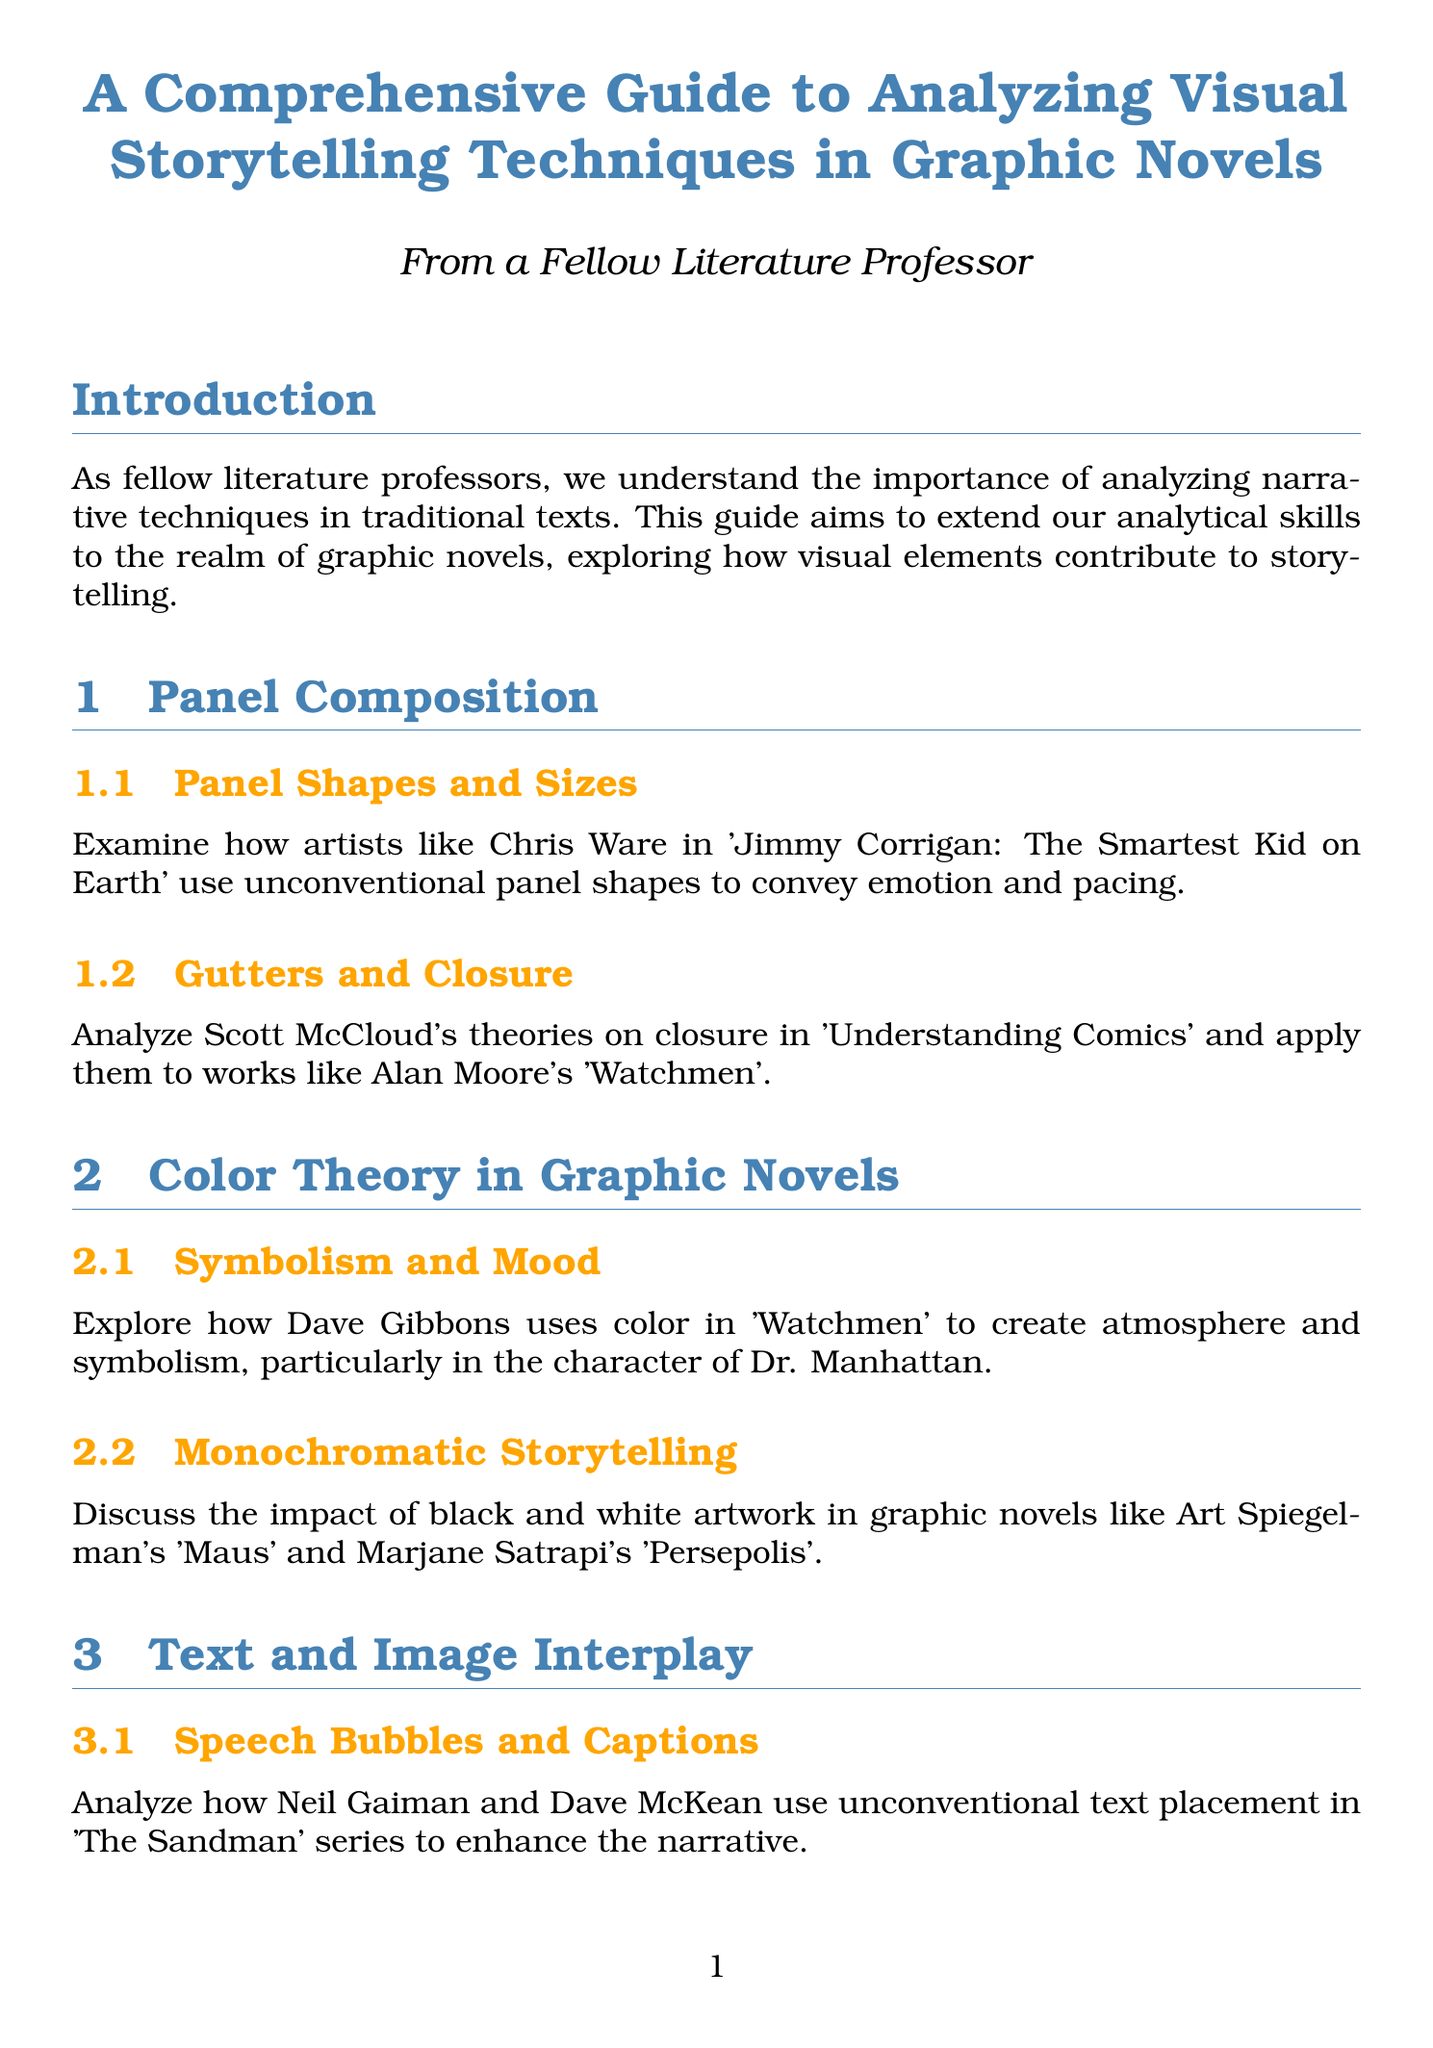What is the title of the guide? The title of the guide is explicitly stated at the beginning of the document.
Answer: A Comprehensive Guide to Analyzing Visual Storytelling Techniques in Graphic Novels Who is mentioned as using unconventional panel shapes? The document specifically names an artist who uses unconventional panel shapes to convey emotion.
Answer: Chris Ware Which graphic novel is referenced for analyzing the use of color? The content in the section on color theory mentions a graphic novel that illustrates this theme.
Answer: Watchmen What narrative technique is discussed in the section on page layouts? The document states the significance of a specific narrative technique within the context of page layouts.
Answer: Non-linear storytelling Which artist is noted for conveying complex emotions through facial expressions? The document identifies an artist known for their representation of emotions through character expressions.
Answer: Fiona Staples What type of visual elements are analyzed in "Blankets"? The guide discusses a specific technique used in Craig Thompson's work, highlighting key visual elements.
Answer: Recurring visual motifs Name one book included in the recommended reading list. The recommended reading section lists several books, one of which can be named directly.
Answer: Understanding Comics What is the significance of double-page spreads according to the document? The content specifies a particular aspect of double-page spreads in engaging the reader.
Answer: Pacing and reader engagement Who is associated with the term meta-commentary in visualization? The document lists an artist known for their use of self-referential visuals.
Answer: Grant Morrison 